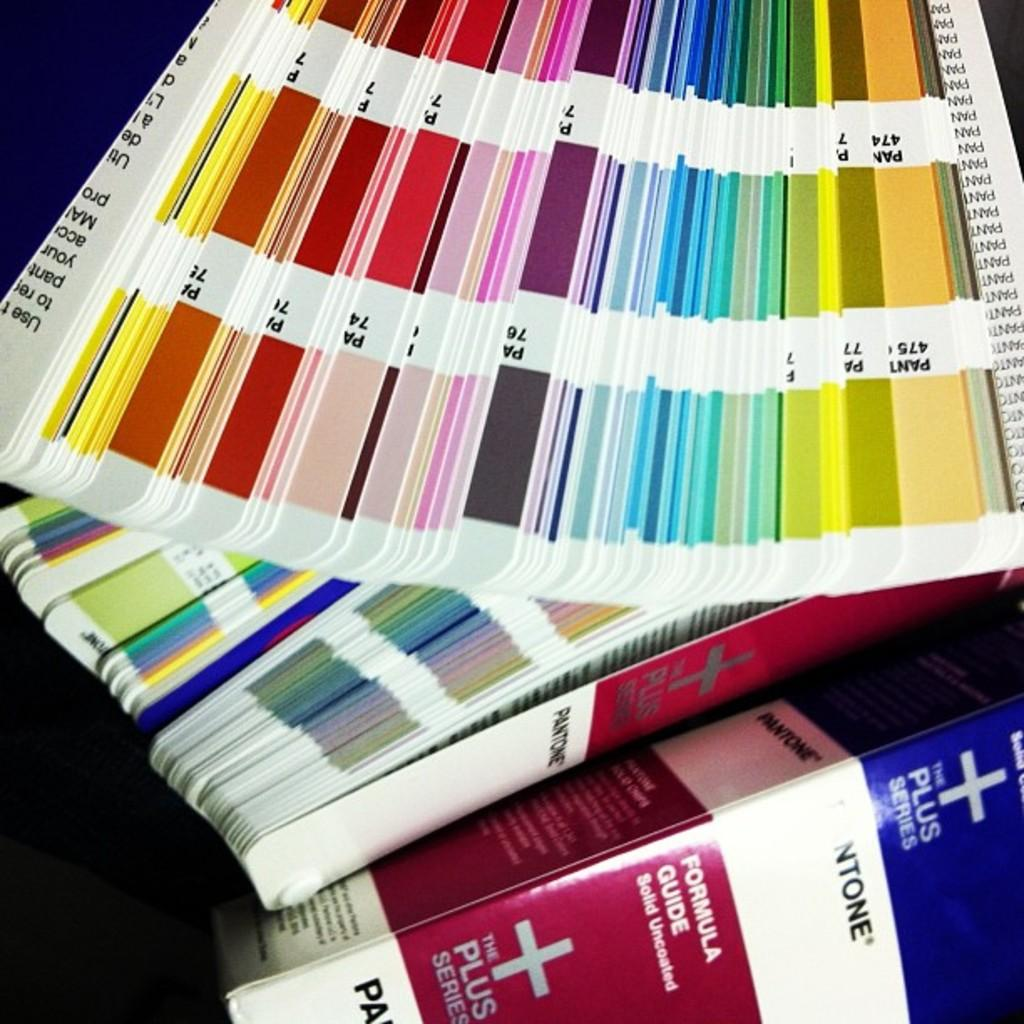<image>
Create a compact narrative representing the image presented. A series of different colored pages next to a Pantone Formula Guide. 